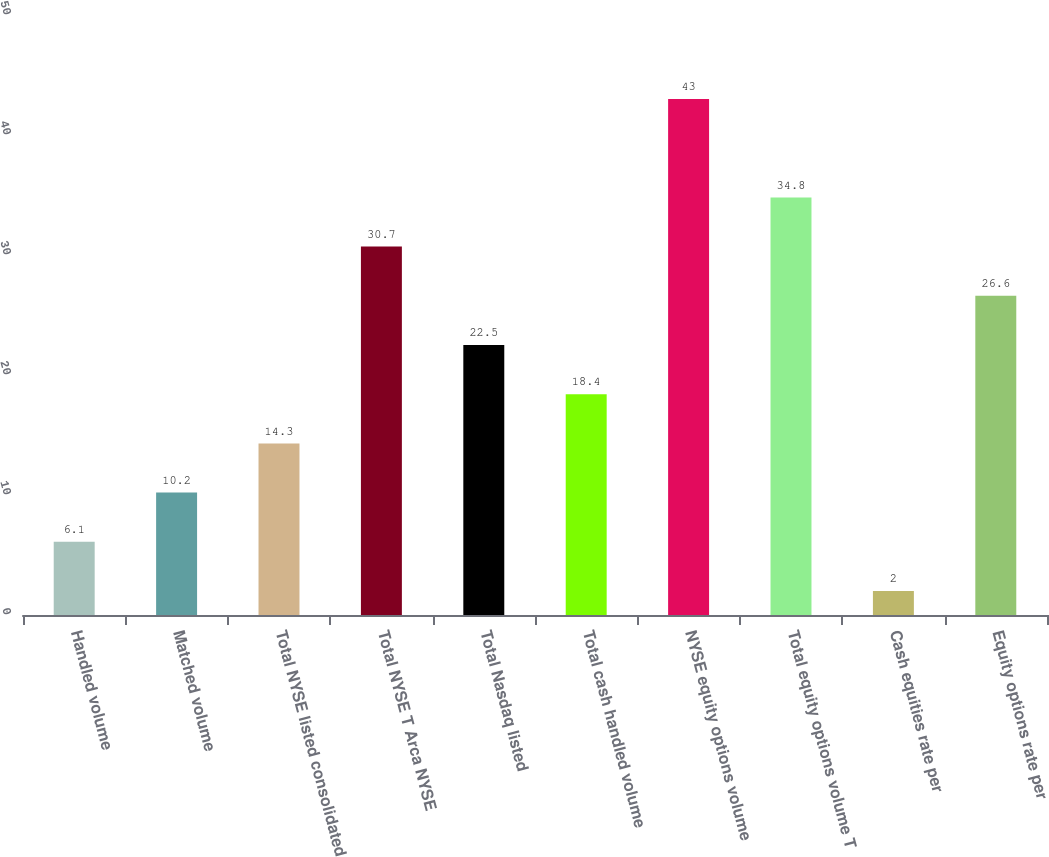Convert chart. <chart><loc_0><loc_0><loc_500><loc_500><bar_chart><fcel>Handled volume<fcel>Matched volume<fcel>Total NYSE listed consolidated<fcel>Total NYSE T Arca NYSE<fcel>Total Nasdaq listed<fcel>Total cash handled volume<fcel>NYSE equity options volume<fcel>Total equity options volume T<fcel>Cash equities rate per<fcel>Equity options rate per<nl><fcel>6.1<fcel>10.2<fcel>14.3<fcel>30.7<fcel>22.5<fcel>18.4<fcel>43<fcel>34.8<fcel>2<fcel>26.6<nl></chart> 